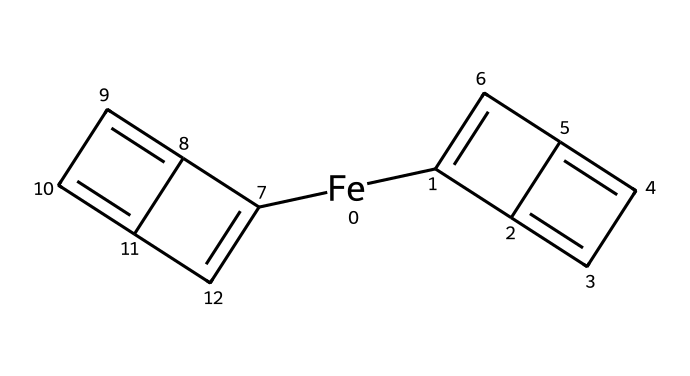What is the central metal atom in ferrocene? The SMILES representation indicates the presence of an iron atom ([Fe]), which is located at the center of the structure, confirming it as the central metal atom.
Answer: iron How many cyclopentadienyl rings are present in ferrocene? Analyzing the SMILES representation reveals two distinct parts that match the structure of cyclopentadienyl rings (C1=C...C3=C), indicating that there are two such rings.
Answer: 2 What is the oxidation state of iron in ferrocene? Since ferrocene is known as a neutral organometallic compound where the cyclopentadienyl anions contribute negatively, the oxidation state of iron must be +2 to balance the overall neutral charge.
Answer: +2 What types of bonding interaction predominantly occur in ferrocene? The interactions in ferrocene mainly involve coordinate covalent bonds between the iron atom and the cyclopentadienyl rings, showcasing the unique bonding characteristics of organometallics.
Answer: coordinate covalent Does ferrocene exhibit a sandwich structure? The presence of two parallel cyclopentadienyl rings surrounding the iron atom indicates that it adopts a sandwich structure, which is characteristic of ferrocene as an organometallic compound.
Answer: yes What is the hybridization of the iron atom in ferrocene? The iron atom in ferrocene, involved in forming bonding interactions with the π-electron cloud from the cyclopentadienyl rings, adopts a hybridization state consistent with d-orbital involvement, often classified as sp3d.
Answer: sp3d What is the overall symmetry of ferrocene? The symmetrical arrangement of the two cyclopentadienyl rings around the central iron atom suggests that ferrocene possesses D5h symmetry, a key feature in its molecular geometry.
Answer: D5h 